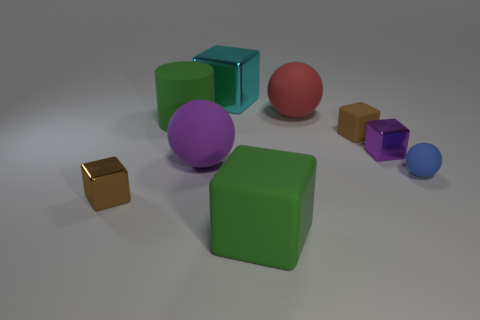Are there the same number of large green blocks that are in front of the small brown metallic object and small purple cubes that are to the left of the red rubber ball?
Your answer should be very brief. No. There is a purple object behind the big purple matte sphere; what is its size?
Offer a terse response. Small. Is there a red sphere that has the same material as the green cylinder?
Your response must be concise. Yes. There is a big cube that is in front of the tiny blue thing; is its color the same as the big rubber cylinder?
Your answer should be compact. Yes. Is the number of brown rubber cubes that are to the left of the brown metal block the same as the number of big matte cubes?
Provide a succinct answer. No. Are there any shiny blocks of the same color as the large shiny thing?
Offer a very short reply. No. Is the size of the purple ball the same as the cyan thing?
Offer a terse response. Yes. How big is the green matte thing behind the small brown thing that is behind the blue thing?
Make the answer very short. Large. There is a thing that is in front of the tiny sphere and on the left side of the cyan cube; how big is it?
Keep it short and to the point. Small. How many blue rubber balls are the same size as the rubber cylinder?
Give a very brief answer. 0. 